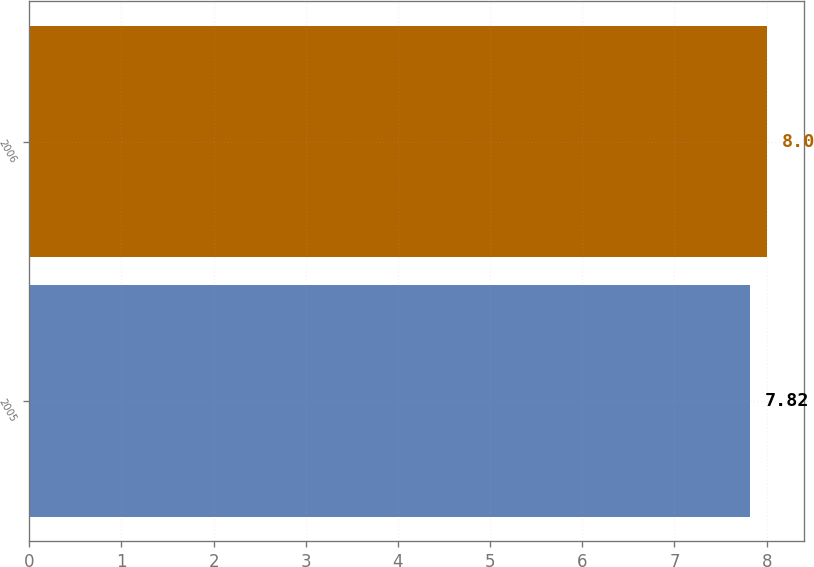Convert chart. <chart><loc_0><loc_0><loc_500><loc_500><bar_chart><fcel>2005<fcel>2006<nl><fcel>7.82<fcel>8<nl></chart> 